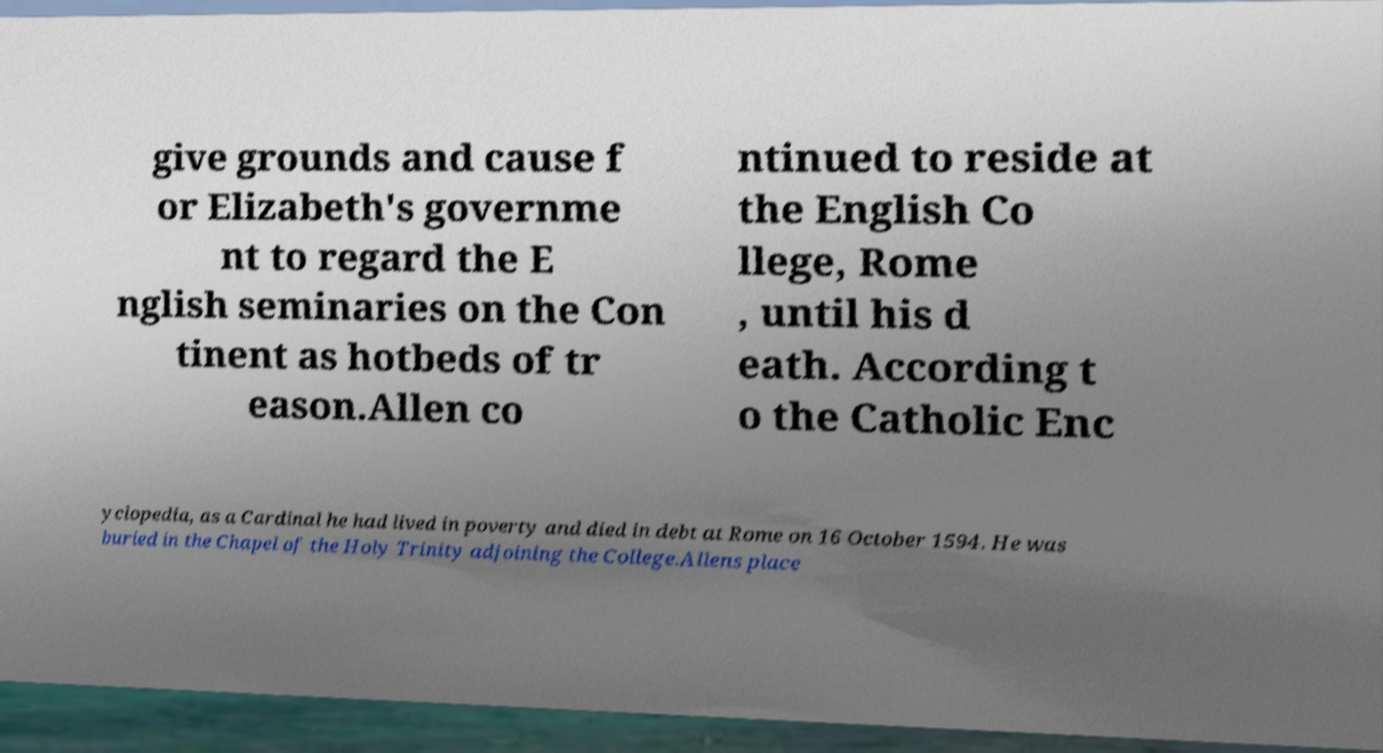Could you extract and type out the text from this image? give grounds and cause f or Elizabeth's governme nt to regard the E nglish seminaries on the Con tinent as hotbeds of tr eason.Allen co ntinued to reside at the English Co llege, Rome , until his d eath. According t o the Catholic Enc yclopedia, as a Cardinal he had lived in poverty and died in debt at Rome on 16 October 1594. He was buried in the Chapel of the Holy Trinity adjoining the College.Allens place 